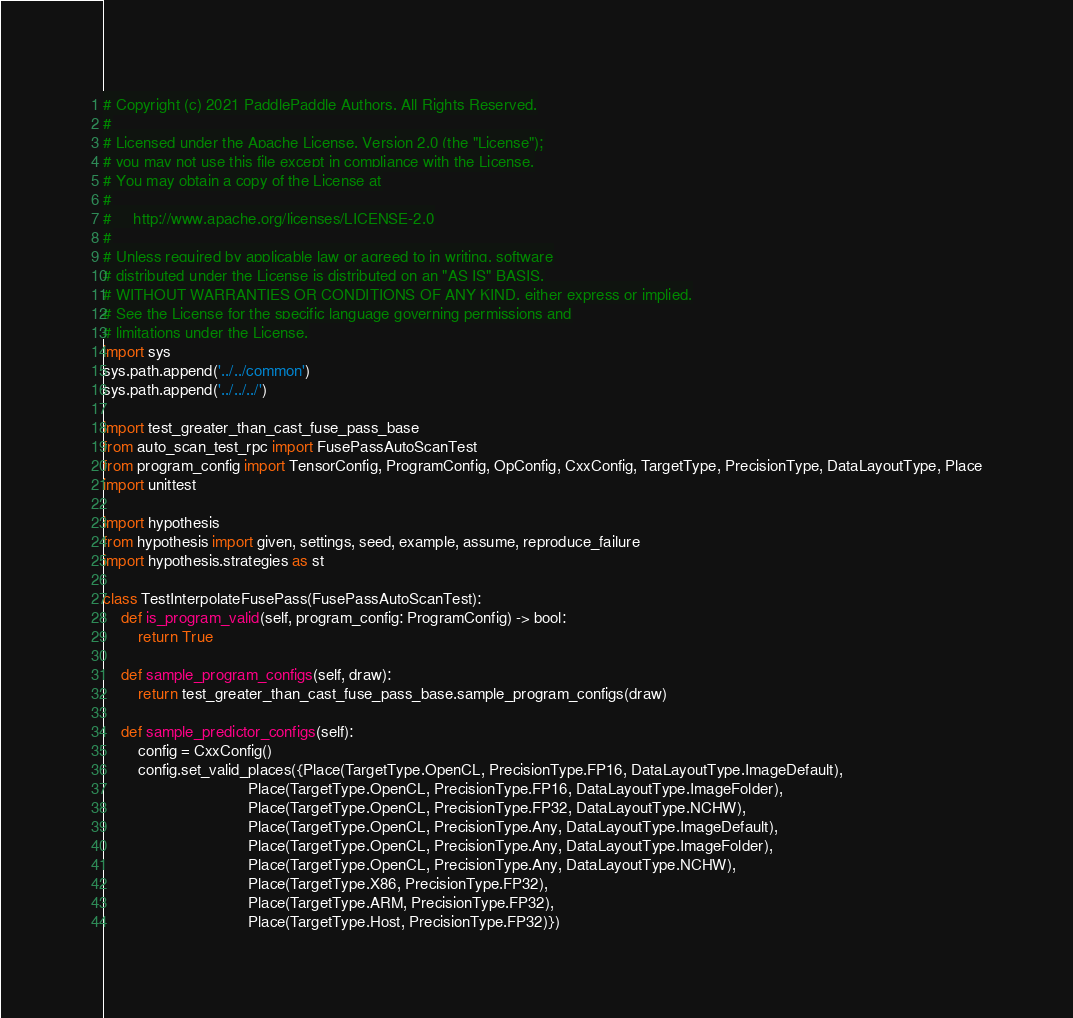Convert code to text. <code><loc_0><loc_0><loc_500><loc_500><_Python_># Copyright (c) 2021 PaddlePaddle Authors. All Rights Reserved.
#
# Licensed under the Apache License, Version 2.0 (the "License");
# you may not use this file except in compliance with the License.
# You may obtain a copy of the License at
#
#     http://www.apache.org/licenses/LICENSE-2.0
#
# Unless required by applicable law or agreed to in writing, software
# distributed under the License is distributed on an "AS IS" BASIS,
# WITHOUT WARRANTIES OR CONDITIONS OF ANY KIND, either express or implied.
# See the License for the specific language governing permissions and
# limitations under the License.
import sys
sys.path.append('../../common')
sys.path.append('../../../')

import test_greater_than_cast_fuse_pass_base 
from auto_scan_test_rpc import FusePassAutoScanTest
from program_config import TensorConfig, ProgramConfig, OpConfig, CxxConfig, TargetType, PrecisionType, DataLayoutType, Place
import unittest

import hypothesis
from hypothesis import given, settings, seed, example, assume, reproduce_failure
import hypothesis.strategies as st

class TestInterpolateFusePass(FusePassAutoScanTest):
    def is_program_valid(self, program_config: ProgramConfig) -> bool:
        return True

    def sample_program_configs(self, draw):
        return test_greater_than_cast_fuse_pass_base.sample_program_configs(draw)

    def sample_predictor_configs(self):
        config = CxxConfig()
        config.set_valid_places({Place(TargetType.OpenCL, PrecisionType.FP16, DataLayoutType.ImageDefault),
                                 Place(TargetType.OpenCL, PrecisionType.FP16, DataLayoutType.ImageFolder),
                                 Place(TargetType.OpenCL, PrecisionType.FP32, DataLayoutType.NCHW),
                                 Place(TargetType.OpenCL, PrecisionType.Any, DataLayoutType.ImageDefault),
                                 Place(TargetType.OpenCL, PrecisionType.Any, DataLayoutType.ImageFolder),
                                 Place(TargetType.OpenCL, PrecisionType.Any, DataLayoutType.NCHW),
                                 Place(TargetType.X86, PrecisionType.FP32),
                                 Place(TargetType.ARM, PrecisionType.FP32),
                                 Place(TargetType.Host, PrecisionType.FP32)})</code> 